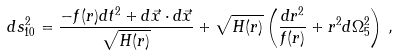Convert formula to latex. <formula><loc_0><loc_0><loc_500><loc_500>d s ^ { 2 } _ { 1 0 } = \frac { - f ( r ) d t ^ { 2 } + d \vec { x } \cdot d \vec { x } } { \sqrt { H ( r ) } } + \sqrt { H ( r ) } \left ( \frac { d r ^ { 2 } } { f ( r ) } + r ^ { 2 } d \Omega _ { 5 } ^ { 2 } \right ) \, ,</formula> 